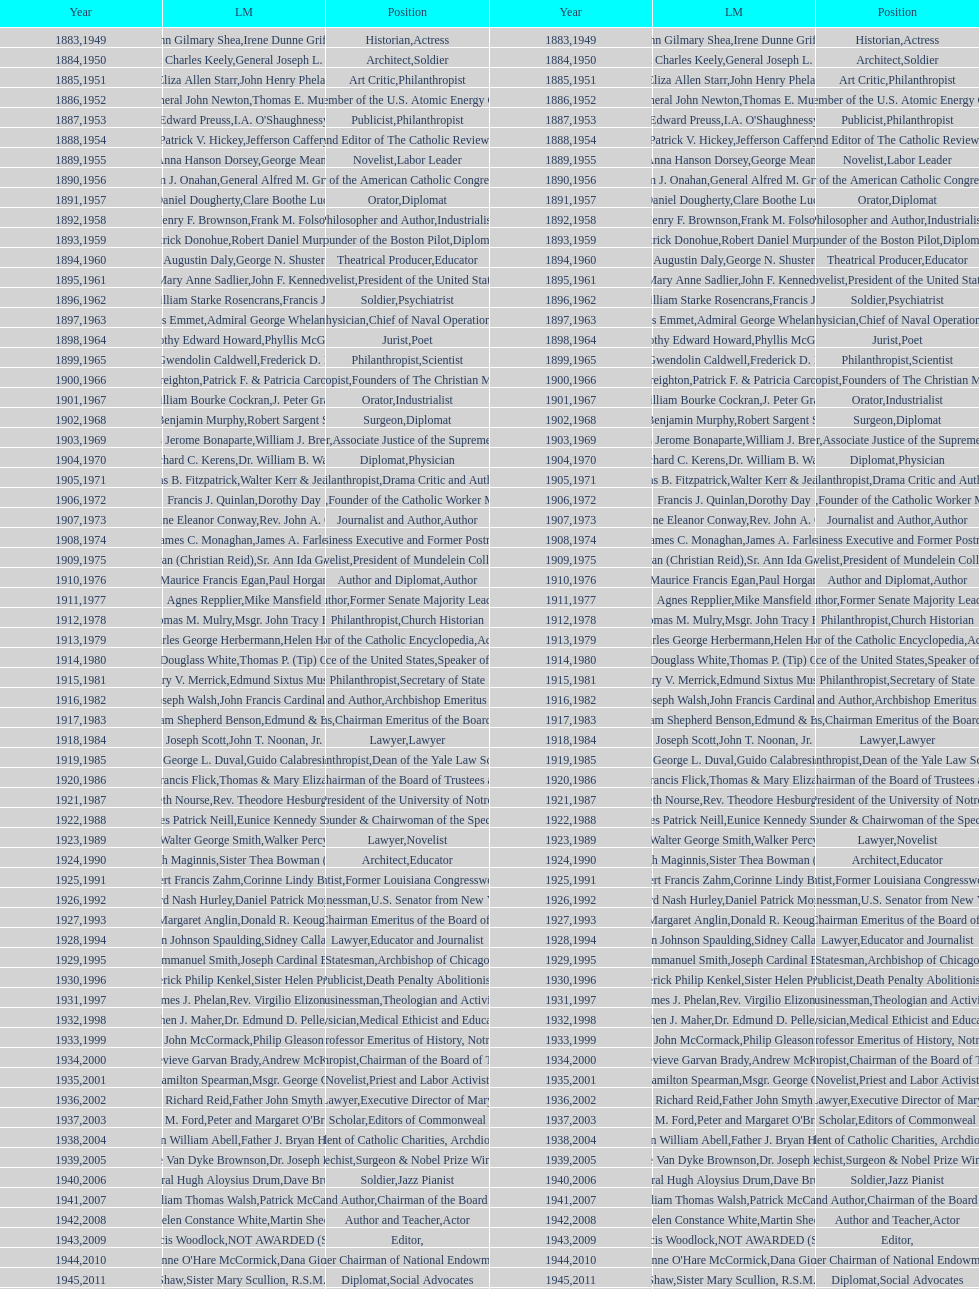Would you be able to parse every entry in this table? {'header': ['Year', 'LM', 'Position', 'Year', 'LM', 'Position'], 'rows': [['1883', 'John Gilmary Shea', 'Historian', '1949', 'Irene Dunne Griffin', 'Actress'], ['1884', 'Patrick Charles Keely', 'Architect', '1950', 'General Joseph L. Collins', 'Soldier'], ['1885', 'Eliza Allen Starr', 'Art Critic', '1951', 'John Henry Phelan', 'Philanthropist'], ['1886', 'General John Newton', 'Engineer', '1952', 'Thomas E. Murray', 'Member of the U.S. Atomic Energy Commission'], ['1887', 'Edward Preuss', 'Publicist', '1953', "I.A. O'Shaughnessy", 'Philanthropist'], ['1888', 'Patrick V. Hickey', 'Founder and Editor of The Catholic Review', '1954', 'Jefferson Caffery', 'Diplomat'], ['1889', 'Anna Hanson Dorsey', 'Novelist', '1955', 'George Meany', 'Labor Leader'], ['1890', 'William J. Onahan', 'Organizer of the American Catholic Congress', '1956', 'General Alfred M. Gruenther', 'Soldier'], ['1891', 'Daniel Dougherty', 'Orator', '1957', 'Clare Boothe Luce', 'Diplomat'], ['1892', 'Henry F. Brownson', 'Philosopher and Author', '1958', 'Frank M. Folsom', 'Industrialist'], ['1893', 'Patrick Donohue', 'Founder of the Boston Pilot', '1959', 'Robert Daniel Murphy', 'Diplomat'], ['1894', 'Augustin Daly', 'Theatrical Producer', '1960', 'George N. Shuster', 'Educator'], ['1895', 'Mary Anne Sadlier', 'Novelist', '1961', 'John F. Kennedy', 'President of the United States'], ['1896', 'General William Starke Rosencrans', 'Soldier', '1962', 'Francis J. Braceland', 'Psychiatrist'], ['1897', 'Thomas Addis Emmet', 'Physician', '1963', 'Admiral George Whelan Anderson, Jr.', 'Chief of Naval Operations'], ['1898', 'Timothy Edward Howard', 'Jurist', '1964', 'Phyllis McGinley', 'Poet'], ['1899', 'Mary Gwendolin Caldwell', 'Philanthropist', '1965', 'Frederick D. Rossini', 'Scientist'], ['1900', 'John A. Creighton', 'Philanthropist', '1966', 'Patrick F. & Patricia Caron Crowley', 'Founders of The Christian Movement'], ['1901', 'William Bourke Cockran', 'Orator', '1967', 'J. Peter Grace', 'Industrialist'], ['1902', 'John Benjamin Murphy', 'Surgeon', '1968', 'Robert Sargent Shriver', 'Diplomat'], ['1903', 'Charles Jerome Bonaparte', 'Lawyer', '1969', 'William J. Brennan Jr.', 'Associate Justice of the Supreme Court'], ['1904', 'Richard C. Kerens', 'Diplomat', '1970', 'Dr. William B. Walsh', 'Physician'], ['1905', 'Thomas B. Fitzpatrick', 'Philanthropist', '1971', 'Walter Kerr & Jean Kerr', 'Drama Critic and Author'], ['1906', 'Francis J. Quinlan', 'Physician', '1972', 'Dorothy Day', 'Founder of the Catholic Worker Movement'], ['1907', 'Katherine Eleanor Conway', 'Journalist and Author', '1973', "Rev. John A. O'Brien", 'Author'], ['1908', 'James C. Monaghan', 'Economist', '1974', 'James A. Farley', 'Business Executive and Former Postmaster General'], ['1909', 'Frances Tieran (Christian Reid)', 'Novelist', '1975', 'Sr. Ann Ida Gannon, BMV', 'President of Mundelein College'], ['1910', 'Maurice Francis Egan', 'Author and Diplomat', '1976', 'Paul Horgan', 'Author'], ['1911', 'Agnes Repplier', 'Author', '1977', 'Mike Mansfield', 'Former Senate Majority Leader'], ['1912', 'Thomas M. Mulry', 'Philanthropist', '1978', 'Msgr. John Tracy Ellis', 'Church Historian'], ['1913', 'Charles George Herbermann', 'Editor of the Catholic Encyclopedia', '1979', 'Helen Hayes', 'Actress'], ['1914', 'Edward Douglass White', 'Chief Justice of the United States', '1980', "Thomas P. (Tip) O'Neill Jr.", 'Speaker of the House'], ['1915', 'Mary V. Merrick', 'Philanthropist', '1981', 'Edmund Sixtus Muskie', 'Secretary of State'], ['1916', 'James Joseph Walsh', 'Physician and Author', '1982', 'John Francis Cardinal Dearden', 'Archbishop Emeritus of Detroit'], ['1917', 'Admiral William Shepherd Benson', 'Chief of Naval Operations', '1983', 'Edmund & Evelyn Stephan', 'Chairman Emeritus of the Board of Trustees and his wife'], ['1918', 'Joseph Scott', 'Lawyer', '1984', 'John T. Noonan, Jr.', 'Lawyer'], ['1919', 'George L. Duval', 'Philanthropist', '1985', 'Guido Calabresi', 'Dean of the Yale Law School'], ['1920', 'Lawrence Francis Flick', 'Physician', '1986', 'Thomas & Mary Elizabeth Carney', 'Chairman of the Board of Trustees and his wife'], ['1921', 'Elizabeth Nourse', 'Artist', '1987', 'Rev. Theodore Hesburgh, CSC', 'President of the University of Notre Dame'], ['1922', 'Charles Patrick Neill', 'Economist', '1988', 'Eunice Kennedy Shriver', 'Founder & Chairwoman of the Special Olympics'], ['1923', 'Walter George Smith', 'Lawyer', '1989', 'Walker Percy', 'Novelist'], ['1924', 'Charles Donagh Maginnis', 'Architect', '1990', 'Sister Thea Bowman (posthumously)', 'Educator'], ['1925', 'Albert Francis Zahm', 'Scientist', '1991', 'Corinne Lindy Boggs', 'Former Louisiana Congresswoman'], ['1926', 'Edward Nash Hurley', 'Businessman', '1992', 'Daniel Patrick Moynihan', 'U.S. Senator from New York'], ['1927', 'Margaret Anglin', 'Actress', '1993', 'Donald R. Keough', 'Chairman Emeritus of the Board of Trustees'], ['1928', 'John Johnson Spaulding', 'Lawyer', '1994', 'Sidney Callahan', 'Educator and Journalist'], ['1929', 'Alfred Emmanuel Smith', 'Statesman', '1995', 'Joseph Cardinal Bernardin', 'Archbishop of Chicago'], ['1930', 'Frederick Philip Kenkel', 'Publicist', '1996', 'Sister Helen Prejean', 'Death Penalty Abolitionist'], ['1931', 'James J. Phelan', 'Businessman', '1997', 'Rev. Virgilio Elizondo', 'Theologian and Activist'], ['1932', 'Stephen J. Maher', 'Physician', '1998', 'Dr. Edmund D. Pellegrino', 'Medical Ethicist and Educator'], ['1933', 'John McCormack', 'Artist', '1999', 'Philip Gleason', 'Professor Emeritus of History, Notre Dame'], ['1934', 'Genevieve Garvan Brady', 'Philanthropist', '2000', 'Andrew McKenna', 'Chairman of the Board of Trustees'], ['1935', 'Francis Hamilton Spearman', 'Novelist', '2001', 'Msgr. George G. Higgins', 'Priest and Labor Activist'], ['1936', 'Richard Reid', 'Journalist and Lawyer', '2002', 'Father John Smyth', 'Executive Director of Maryville Academy'], ['1937', 'Jeremiah D. M. Ford', 'Scholar', '2003', "Peter and Margaret O'Brien Steinfels", 'Editors of Commonweal'], ['1938', 'Irvin William Abell', 'Surgeon', '2004', 'Father J. Bryan Hehir', 'President of Catholic Charities, Archdiocese of Boston'], ['1939', 'Josephine Van Dyke Brownson', 'Catechist', '2005', 'Dr. Joseph E. Murray', 'Surgeon & Nobel Prize Winner'], ['1940', 'General Hugh Aloysius Drum', 'Soldier', '2006', 'Dave Brubeck', 'Jazz Pianist'], ['1941', 'William Thomas Walsh', 'Journalist and Author', '2007', 'Patrick McCartan', 'Chairman of the Board of Trustees'], ['1942', 'Helen Constance White', 'Author and Teacher', '2008', 'Martin Sheen', 'Actor'], ['1943', 'Thomas Francis Woodlock', 'Editor', '2009', 'NOT AWARDED (SEE BELOW)', ''], ['1944', "Anne O'Hare McCormick", 'Journalist', '2010', 'Dana Gioia', 'Former Chairman of National Endowment for the Arts'], ['1945', 'Gardiner Howland Shaw', 'Diplomat', '2011', 'Sister Mary Scullion, R.S.M., & Joan McConnon', 'Social Advocates'], ['1946', 'Carlton J. H. Hayes', 'Historian and Diplomat', '2012', 'Ken Hackett', 'Former President of Catholic Relief Services'], ['1947', 'William G. Bruce', 'Publisher and Civic Leader', '2013', 'Sister Susanne Gallagher, S.P.\\nSister Mary Therese Harrington, S.H.\\nRev. James H. McCarthy', 'Founders of S.P.R.E.D. (Special Religious Education Development Network)'], ['1948', 'Frank C. Walker', 'Postmaster General and Civic Leader', '2014', 'Kenneth R. Miller', 'Professor of Biology at Brown University']]} What is the count of laetare medalists who served as diplomats? 8. 